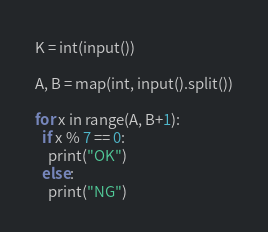Convert code to text. <code><loc_0><loc_0><loc_500><loc_500><_Python_>K = int(input())

A, B = map(int, input().split())

for x in range(A, B+1):
  if x % 7 == 0:
    print("OK")
  else: 
    print("NG")

</code> 